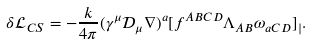Convert formula to latex. <formula><loc_0><loc_0><loc_500><loc_500>\delta \mathcal { L } _ { C S } = - \frac { k } { 4 \pi } ( \gamma ^ { \mu } \mathcal { D } _ { \mu } \nabla ) ^ { a } [ f ^ { A B C D } \Lambda _ { A B } \omega _ { a C D } ] _ { | } .</formula> 